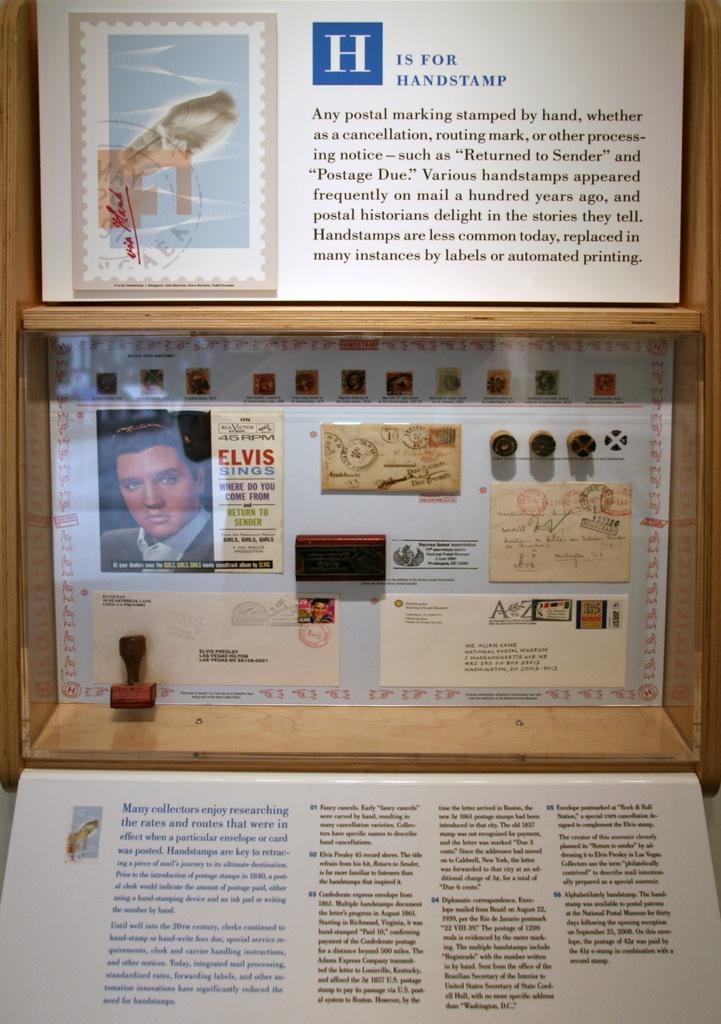<image>
Share a concise interpretation of the image provided. some small poster of stamps and one of them have the name of Elvis on it. 